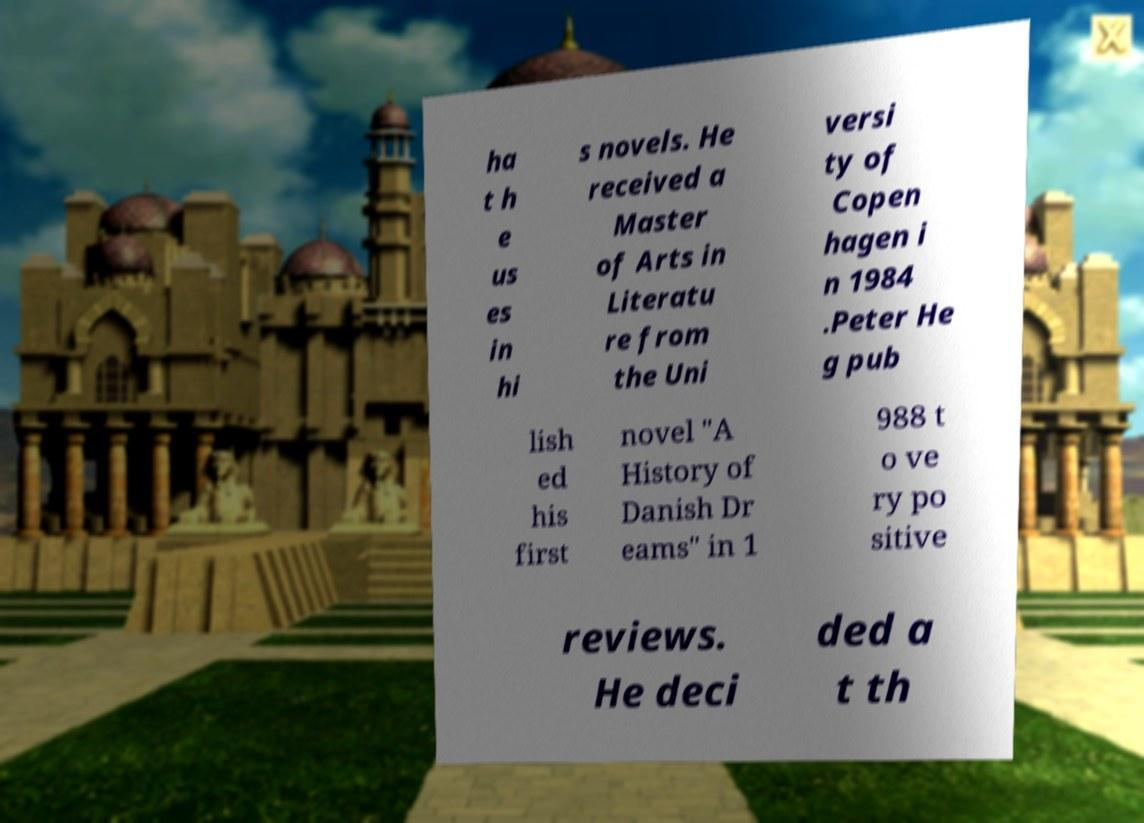Can you accurately transcribe the text from the provided image for me? ha t h e us es in hi s novels. He received a Master of Arts in Literatu re from the Uni versi ty of Copen hagen i n 1984 .Peter He g pub lish ed his first novel "A History of Danish Dr eams" in 1 988 t o ve ry po sitive reviews. He deci ded a t th 